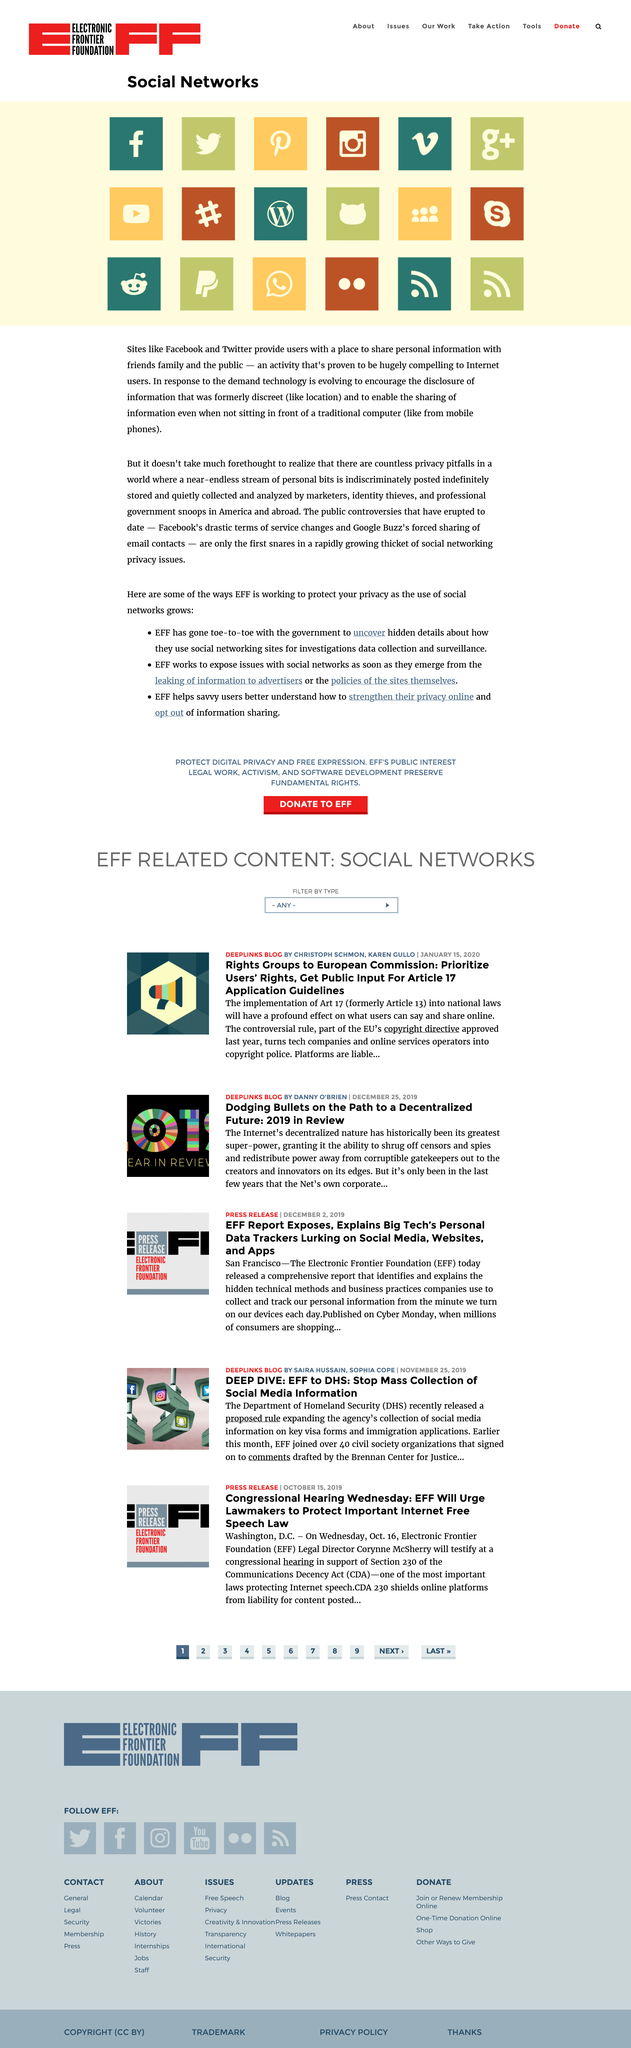Indicate a few pertinent items in this graphic. Facebook and Twitter are examples of sites that provide users with a platform to share personal information with friends, family, and the public, as mentioned in the article. Recent developments, including Facebook's changes to its terms of service and Google Buzz's forced sharing of email contacts, have created a significant thicket of social networking privacy issues that require immediate attention. Yes, this page is primarily about social networks. 